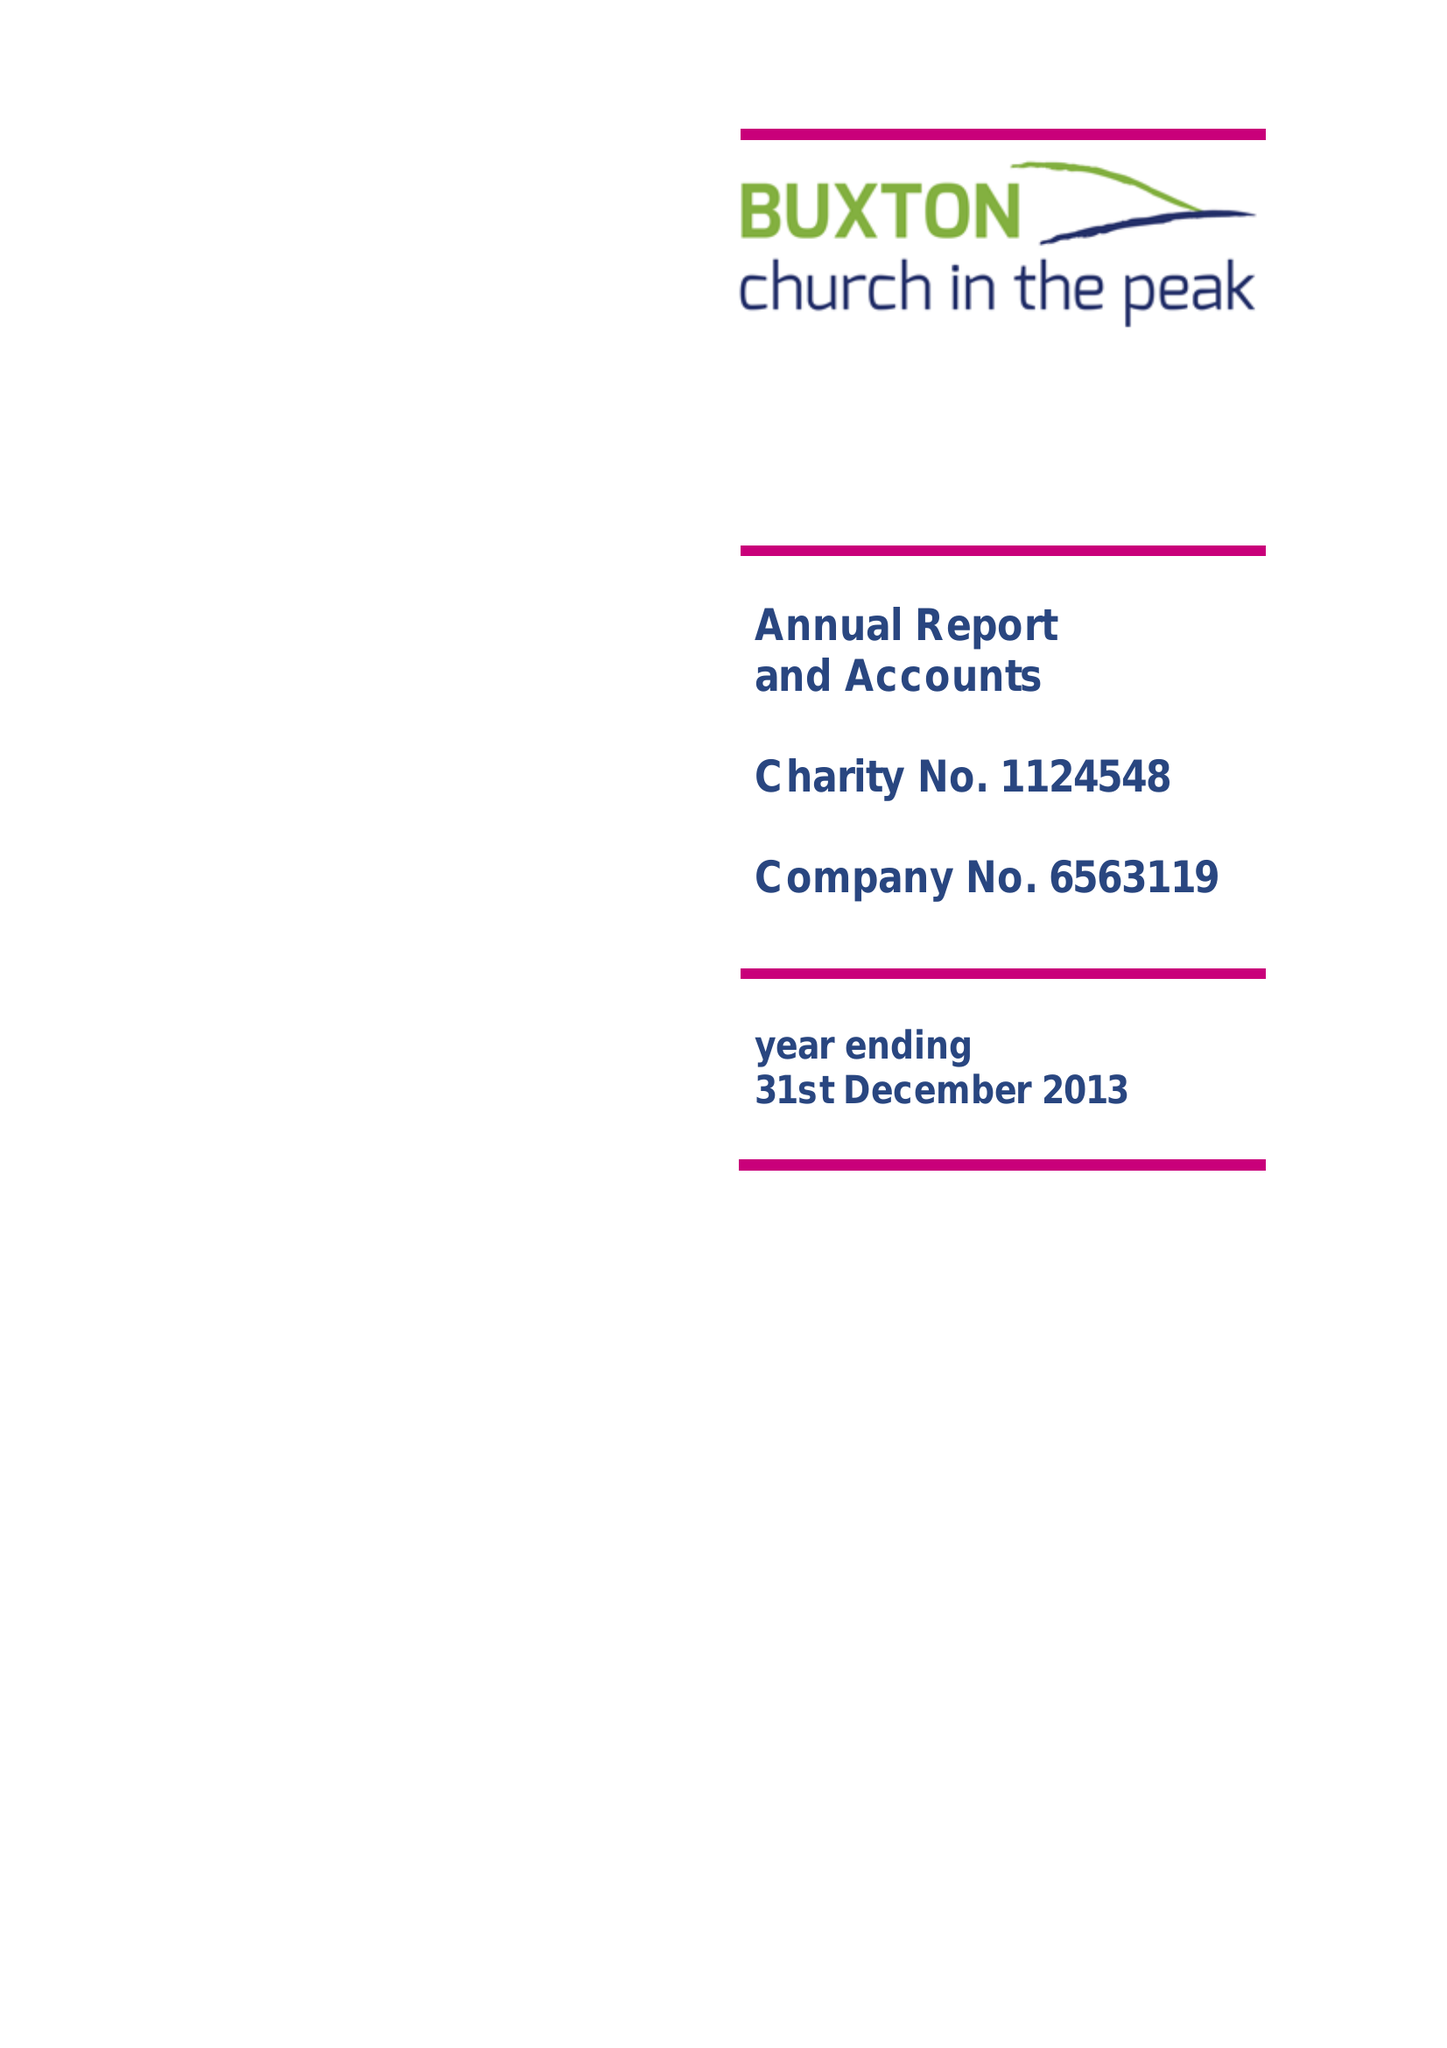What is the value for the address__postcode?
Answer the question using a single word or phrase. SK17 9AD 